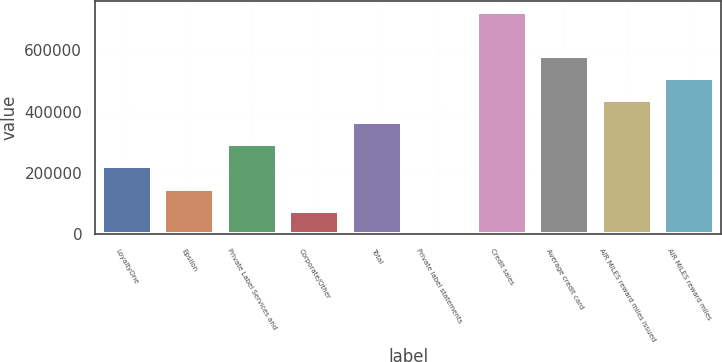Convert chart. <chart><loc_0><loc_0><loc_500><loc_500><bar_chart><fcel>LoyaltyOne<fcel>Epsilon<fcel>Private Label Services and<fcel>Corporate/Other<fcel>Total<fcel>Private label statements<fcel>Credit sales<fcel>Average credit card<fcel>AIR MILES reward miles issued<fcel>AIR MILES reward miles<nl><fcel>221196<fcel>149124<fcel>293269<fcel>77051.4<fcel>365341<fcel>4979<fcel>725703<fcel>581558<fcel>437413<fcel>509486<nl></chart> 